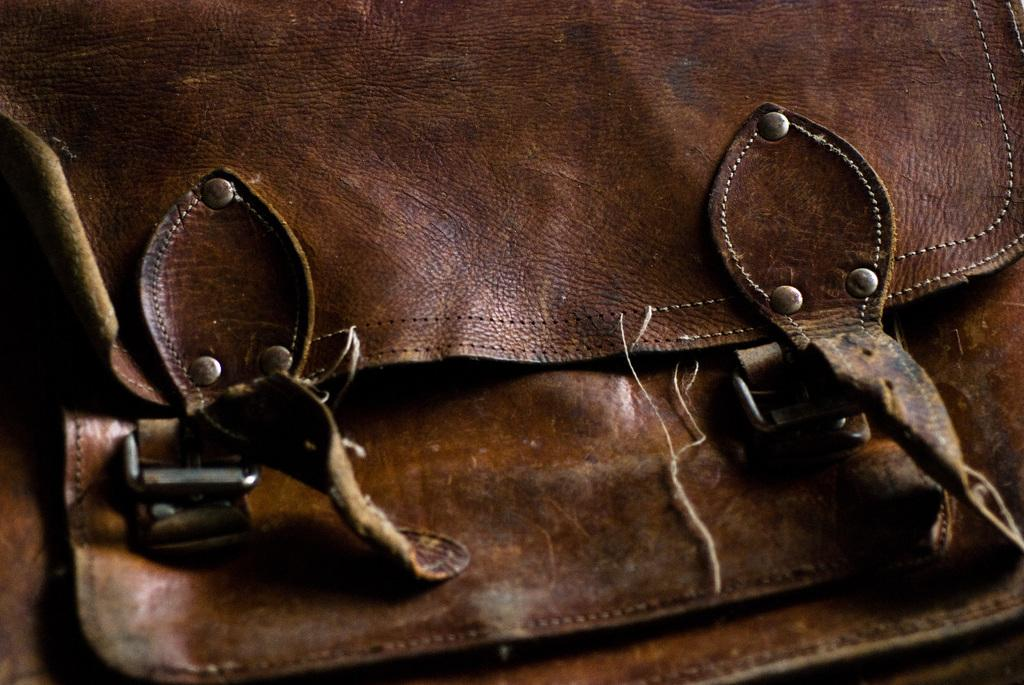What object is present in the image that might be used for carrying items? There is a bag in the image. Can you describe the color of the bag? The bag is in brown color. What type of engine can be seen powering the bag in the image? There is no engine present in the image, and the bag is not powered by any engine. 